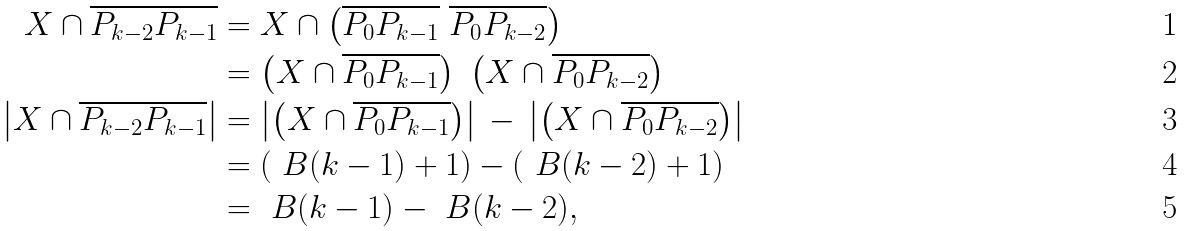<formula> <loc_0><loc_0><loc_500><loc_500>X \cap \overline { P _ { k - 2 } P _ { k - 1 } } & = X \cap \left ( \overline { P _ { 0 } P _ { k - 1 } } \ \overline { P _ { 0 } P _ { k - 2 } } \right ) \\ & = \left ( X \cap \overline { P _ { 0 } P _ { k - 1 } } \right ) \ \left ( X \cap \overline { P _ { 0 } P _ { k - 2 } } \right ) \\ \left | X \cap \overline { P _ { k - 2 } P _ { k - 1 } } \right | & = \left | \left ( X \cap \overline { P _ { 0 } P _ { k - 1 } } \right ) \right | \, - \, \left | \left ( X \cap \overline { P _ { 0 } P _ { k - 2 } } \right ) \right | \\ & = \left ( \ B ( k - 1 ) + 1 \right ) - \left ( \ B ( k - 2 ) + 1 \right ) \\ & = \ B ( k - 1 ) - \ B ( k - 2 ) ,</formula> 